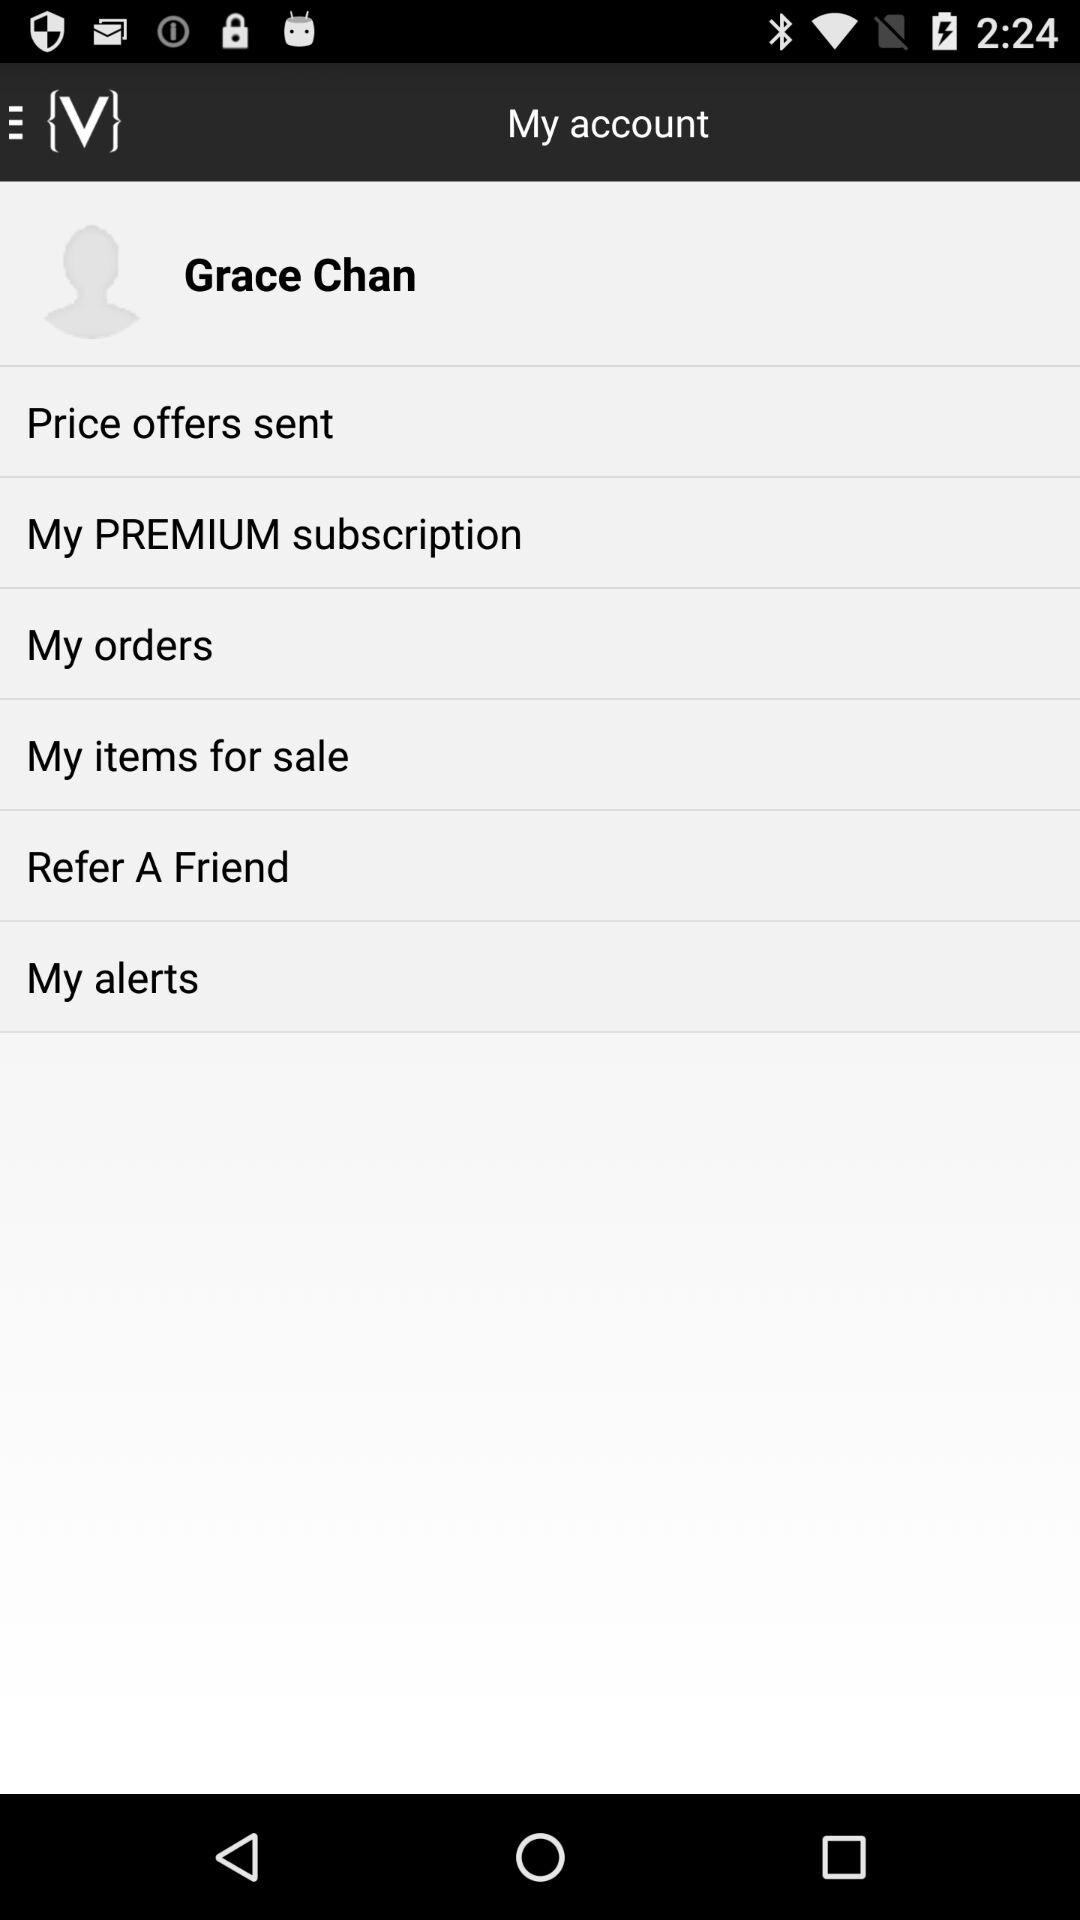What's the user name? The user name is Grace Chan. 